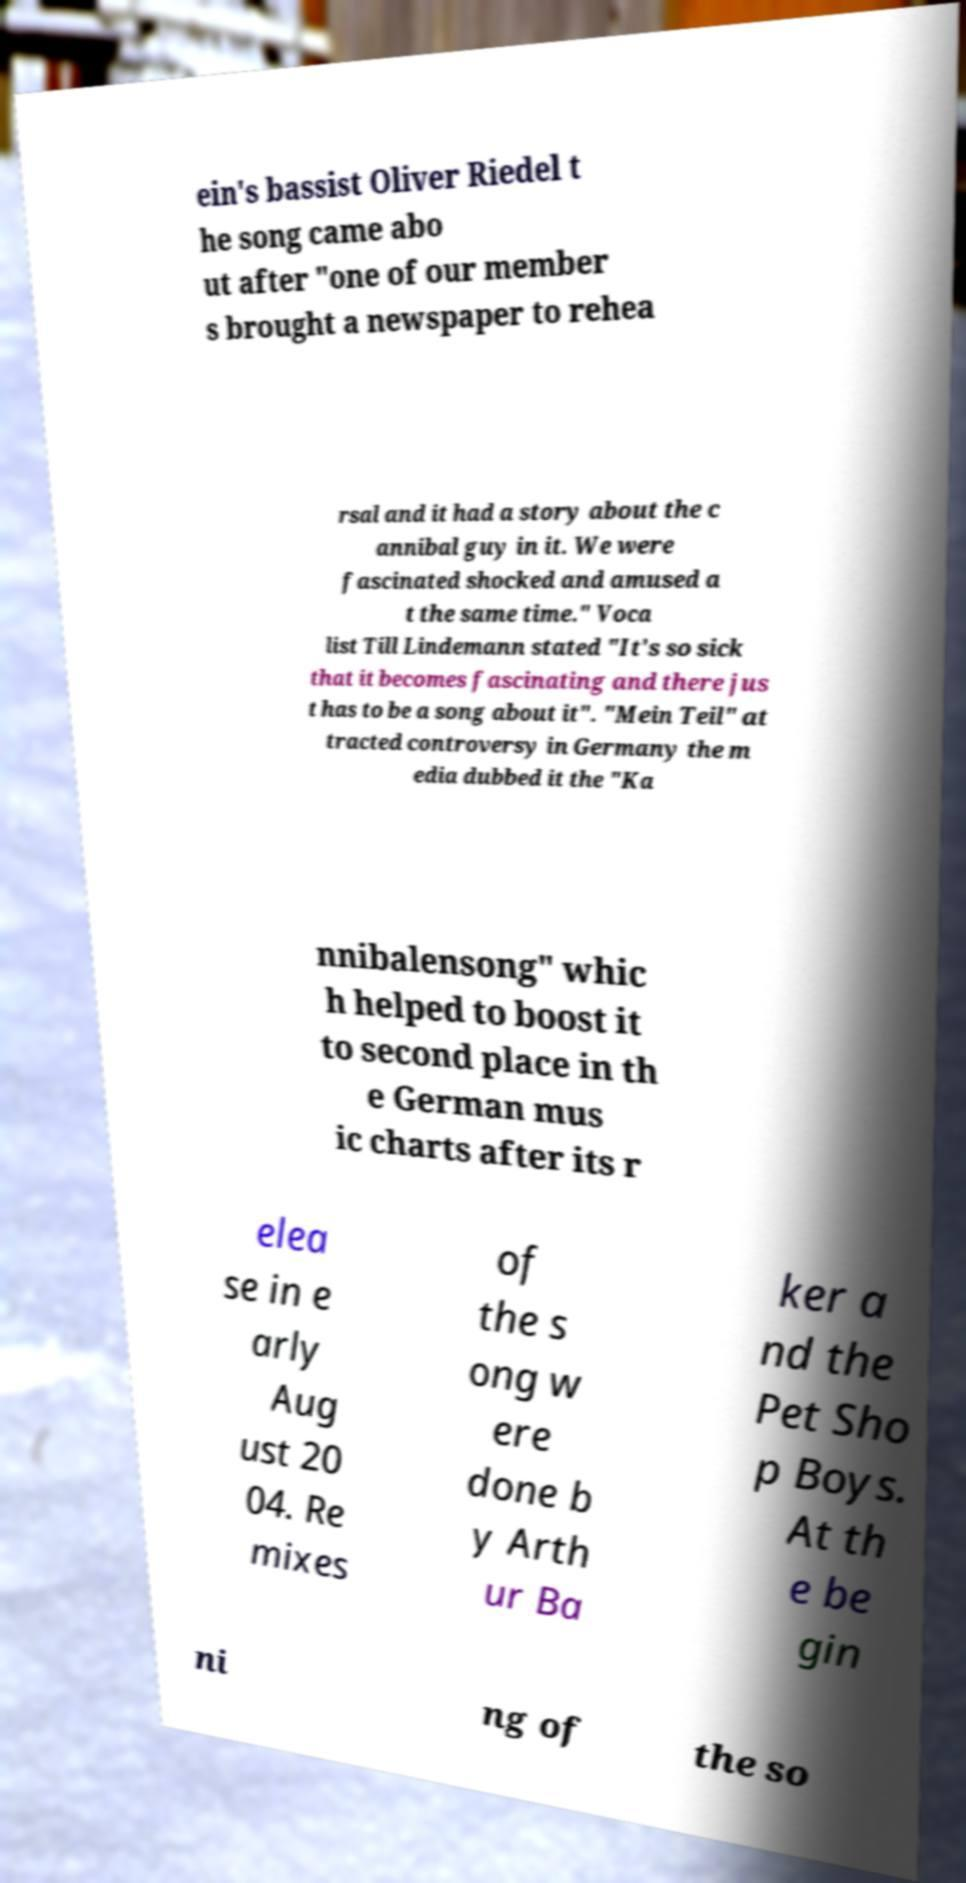Please identify and transcribe the text found in this image. ein's bassist Oliver Riedel t he song came abo ut after "one of our member s brought a newspaper to rehea rsal and it had a story about the c annibal guy in it. We were fascinated shocked and amused a t the same time." Voca list Till Lindemann stated "It's so sick that it becomes fascinating and there jus t has to be a song about it". "Mein Teil" at tracted controversy in Germany the m edia dubbed it the "Ka nnibalensong" whic h helped to boost it to second place in th e German mus ic charts after its r elea se in e arly Aug ust 20 04. Re mixes of the s ong w ere done b y Arth ur Ba ker a nd the Pet Sho p Boys. At th e be gin ni ng of the so 